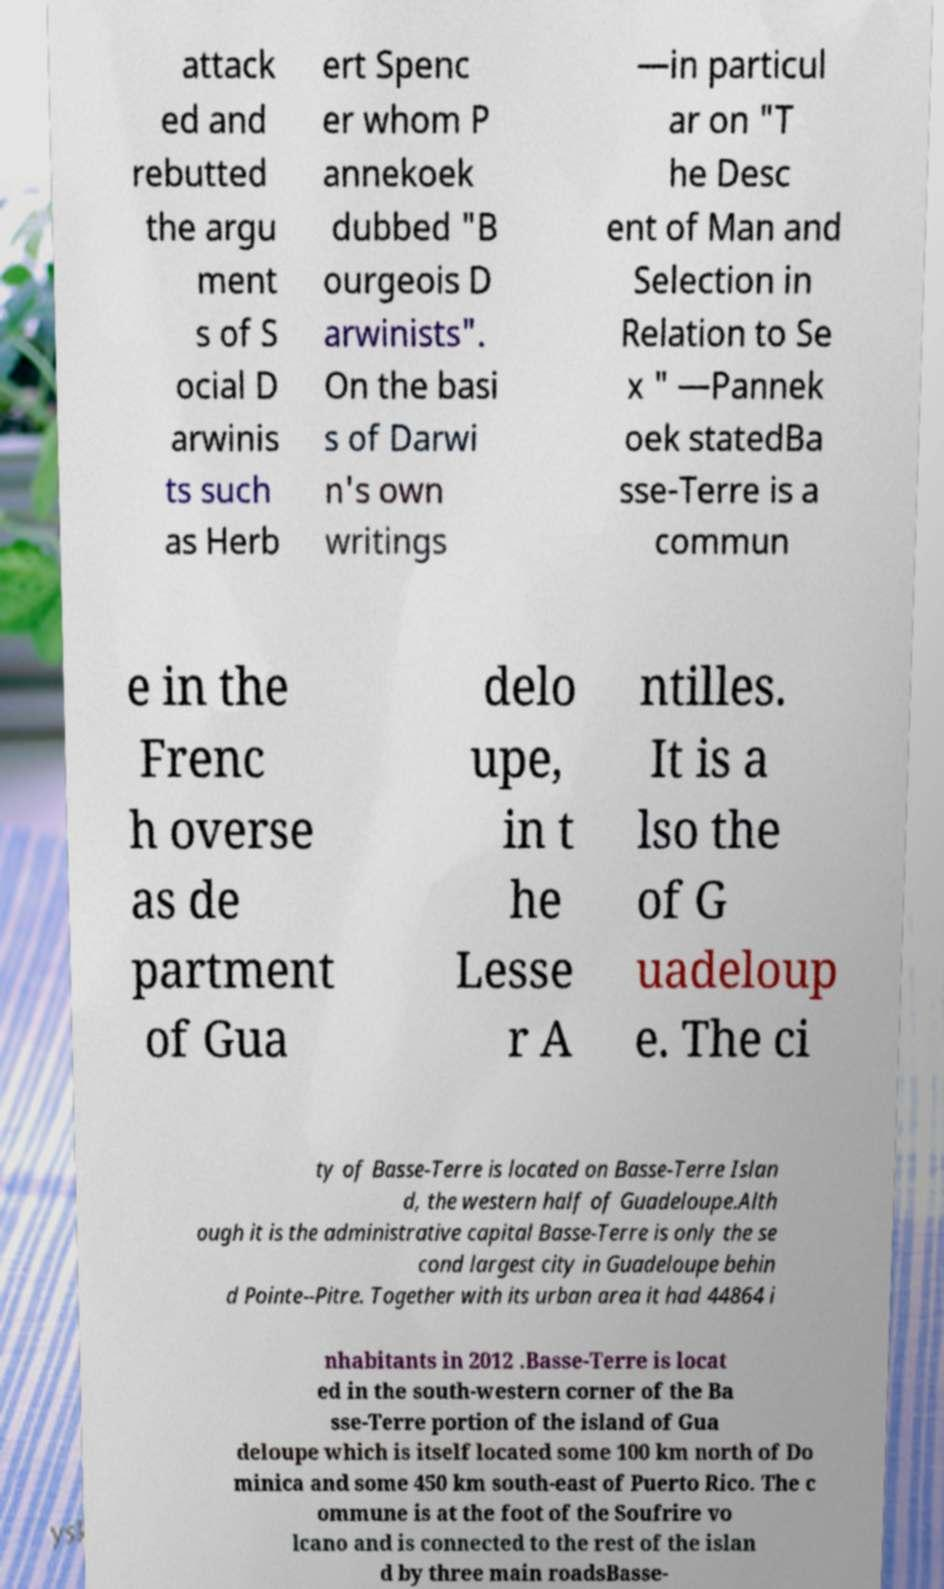There's text embedded in this image that I need extracted. Can you transcribe it verbatim? attack ed and rebutted the argu ment s of S ocial D arwinis ts such as Herb ert Spenc er whom P annekoek dubbed "B ourgeois D arwinists". On the basi s of Darwi n's own writings —in particul ar on "T he Desc ent of Man and Selection in Relation to Se x " —Pannek oek statedBa sse-Terre is a commun e in the Frenc h overse as de partment of Gua delo upe, in t he Lesse r A ntilles. It is a lso the of G uadeloup e. The ci ty of Basse-Terre is located on Basse-Terre Islan d, the western half of Guadeloupe.Alth ough it is the administrative capital Basse-Terre is only the se cond largest city in Guadeloupe behin d Pointe--Pitre. Together with its urban area it had 44864 i nhabitants in 2012 .Basse-Terre is locat ed in the south-western corner of the Ba sse-Terre portion of the island of Gua deloupe which is itself located some 100 km north of Do minica and some 450 km south-east of Puerto Rico. The c ommune is at the foot of the Soufrire vo lcano and is connected to the rest of the islan d by three main roadsBasse- 